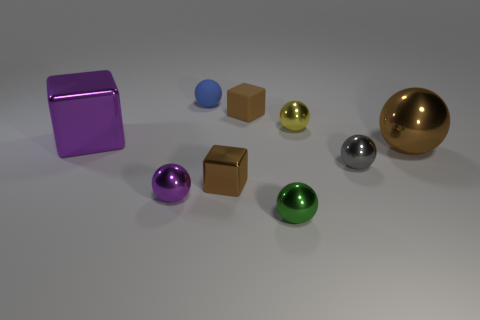Is there anything else of the same color as the rubber ball?
Offer a terse response. No. Are there more small purple objects that are on the right side of the small gray metal thing than big gray metallic things?
Provide a short and direct response. No. Is the yellow shiny sphere the same size as the purple shiny cube?
Provide a succinct answer. No. There is a small blue object that is the same shape as the small yellow metal object; what is it made of?
Provide a succinct answer. Rubber. How many gray things are either big metallic balls or small things?
Make the answer very short. 1. What is the tiny brown object in front of the big purple metallic thing made of?
Give a very brief answer. Metal. Are there more purple metal things than small gray matte blocks?
Your response must be concise. Yes. There is a large thing left of the yellow metallic thing; is its shape the same as the tiny brown rubber thing?
Keep it short and to the point. Yes. How many cubes are on the right side of the blue object and behind the tiny gray metal object?
Provide a short and direct response. 1. What number of big green matte things have the same shape as the blue rubber thing?
Ensure brevity in your answer.  0. 